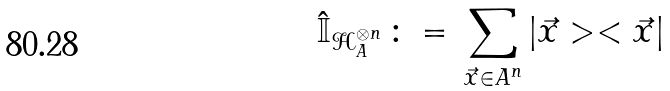<formula> <loc_0><loc_0><loc_500><loc_500>\hat { \mathbb { I } } _ { \mathcal { H } _ { A } ^ { \otimes n } } \, \colon = \, \sum _ { \vec { x } \in A ^ { n } } | \vec { x } > < \vec { x } |</formula> 